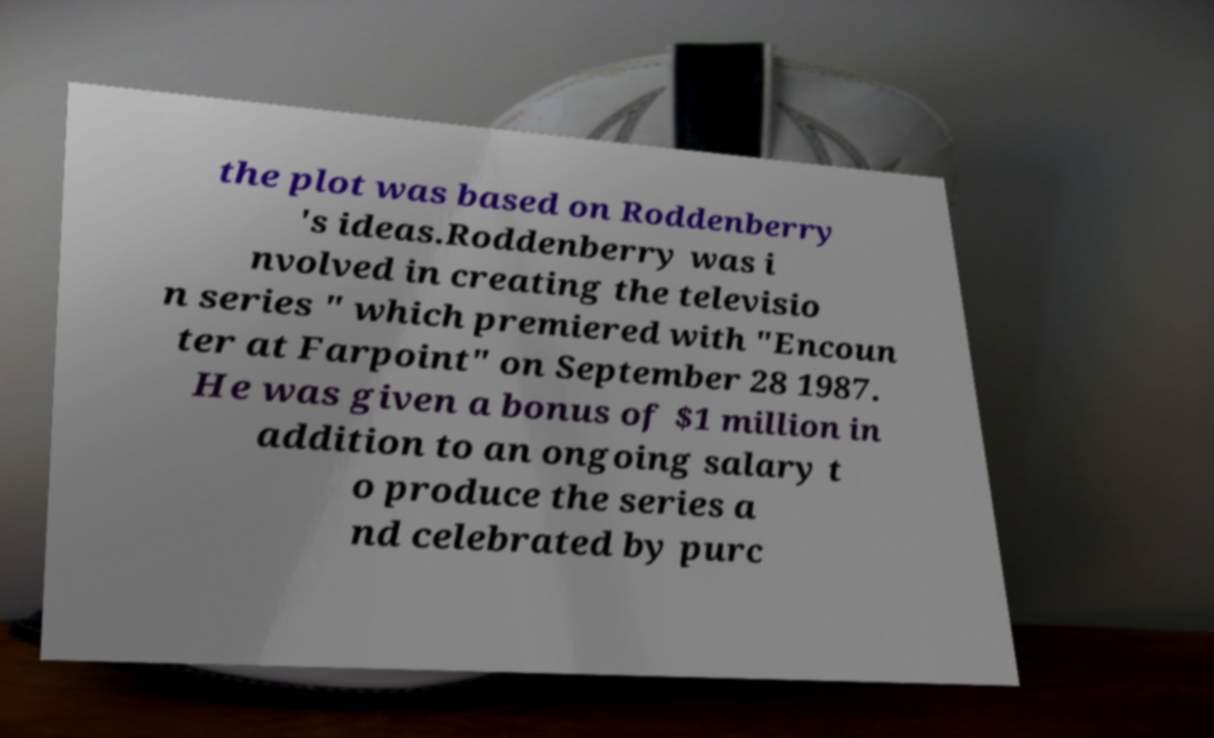For documentation purposes, I need the text within this image transcribed. Could you provide that? the plot was based on Roddenberry 's ideas.Roddenberry was i nvolved in creating the televisio n series " which premiered with "Encoun ter at Farpoint" on September 28 1987. He was given a bonus of $1 million in addition to an ongoing salary t o produce the series a nd celebrated by purc 